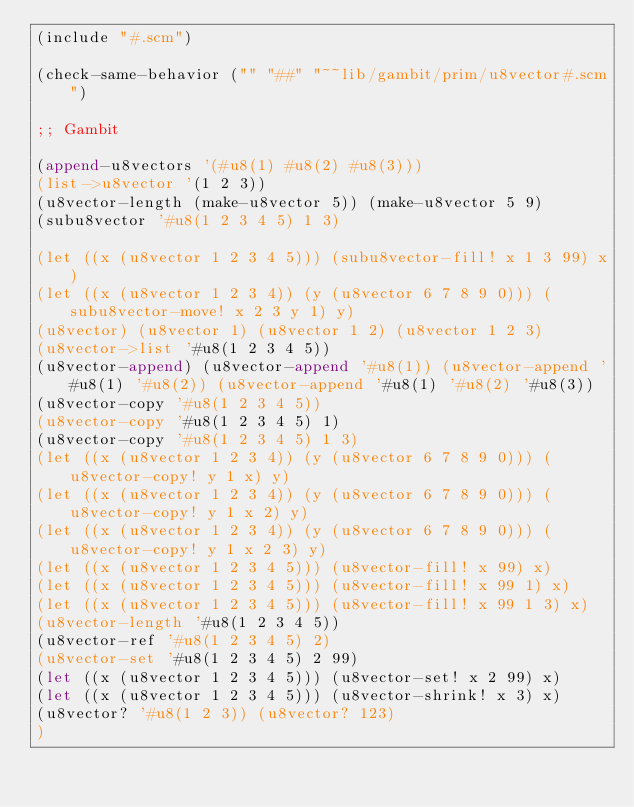<code> <loc_0><loc_0><loc_500><loc_500><_Scheme_>(include "#.scm")

(check-same-behavior ("" "##" "~~lib/gambit/prim/u8vector#.scm")

;; Gambit

(append-u8vectors '(#u8(1) #u8(2) #u8(3)))
(list->u8vector '(1 2 3))
(u8vector-length (make-u8vector 5)) (make-u8vector 5 9)
(subu8vector '#u8(1 2 3 4 5) 1 3)

(let ((x (u8vector 1 2 3 4 5))) (subu8vector-fill! x 1 3 99) x)
(let ((x (u8vector 1 2 3 4)) (y (u8vector 6 7 8 9 0))) (subu8vector-move! x 2 3 y 1) y)
(u8vector) (u8vector 1) (u8vector 1 2) (u8vector 1 2 3)
(u8vector->list '#u8(1 2 3 4 5))
(u8vector-append) (u8vector-append '#u8(1)) (u8vector-append '#u8(1) '#u8(2)) (u8vector-append '#u8(1) '#u8(2) '#u8(3))
(u8vector-copy '#u8(1 2 3 4 5))
(u8vector-copy '#u8(1 2 3 4 5) 1)
(u8vector-copy '#u8(1 2 3 4 5) 1 3)
(let ((x (u8vector 1 2 3 4)) (y (u8vector 6 7 8 9 0))) (u8vector-copy! y 1 x) y)
(let ((x (u8vector 1 2 3 4)) (y (u8vector 6 7 8 9 0))) (u8vector-copy! y 1 x 2) y)
(let ((x (u8vector 1 2 3 4)) (y (u8vector 6 7 8 9 0))) (u8vector-copy! y 1 x 2 3) y)
(let ((x (u8vector 1 2 3 4 5))) (u8vector-fill! x 99) x)
(let ((x (u8vector 1 2 3 4 5))) (u8vector-fill! x 99 1) x)
(let ((x (u8vector 1 2 3 4 5))) (u8vector-fill! x 99 1 3) x)
(u8vector-length '#u8(1 2 3 4 5))
(u8vector-ref '#u8(1 2 3 4 5) 2)
(u8vector-set '#u8(1 2 3 4 5) 2 99)
(let ((x (u8vector 1 2 3 4 5))) (u8vector-set! x 2 99) x)
(let ((x (u8vector 1 2 3 4 5))) (u8vector-shrink! x 3) x)
(u8vector? '#u8(1 2 3)) (u8vector? 123)
)
</code> 